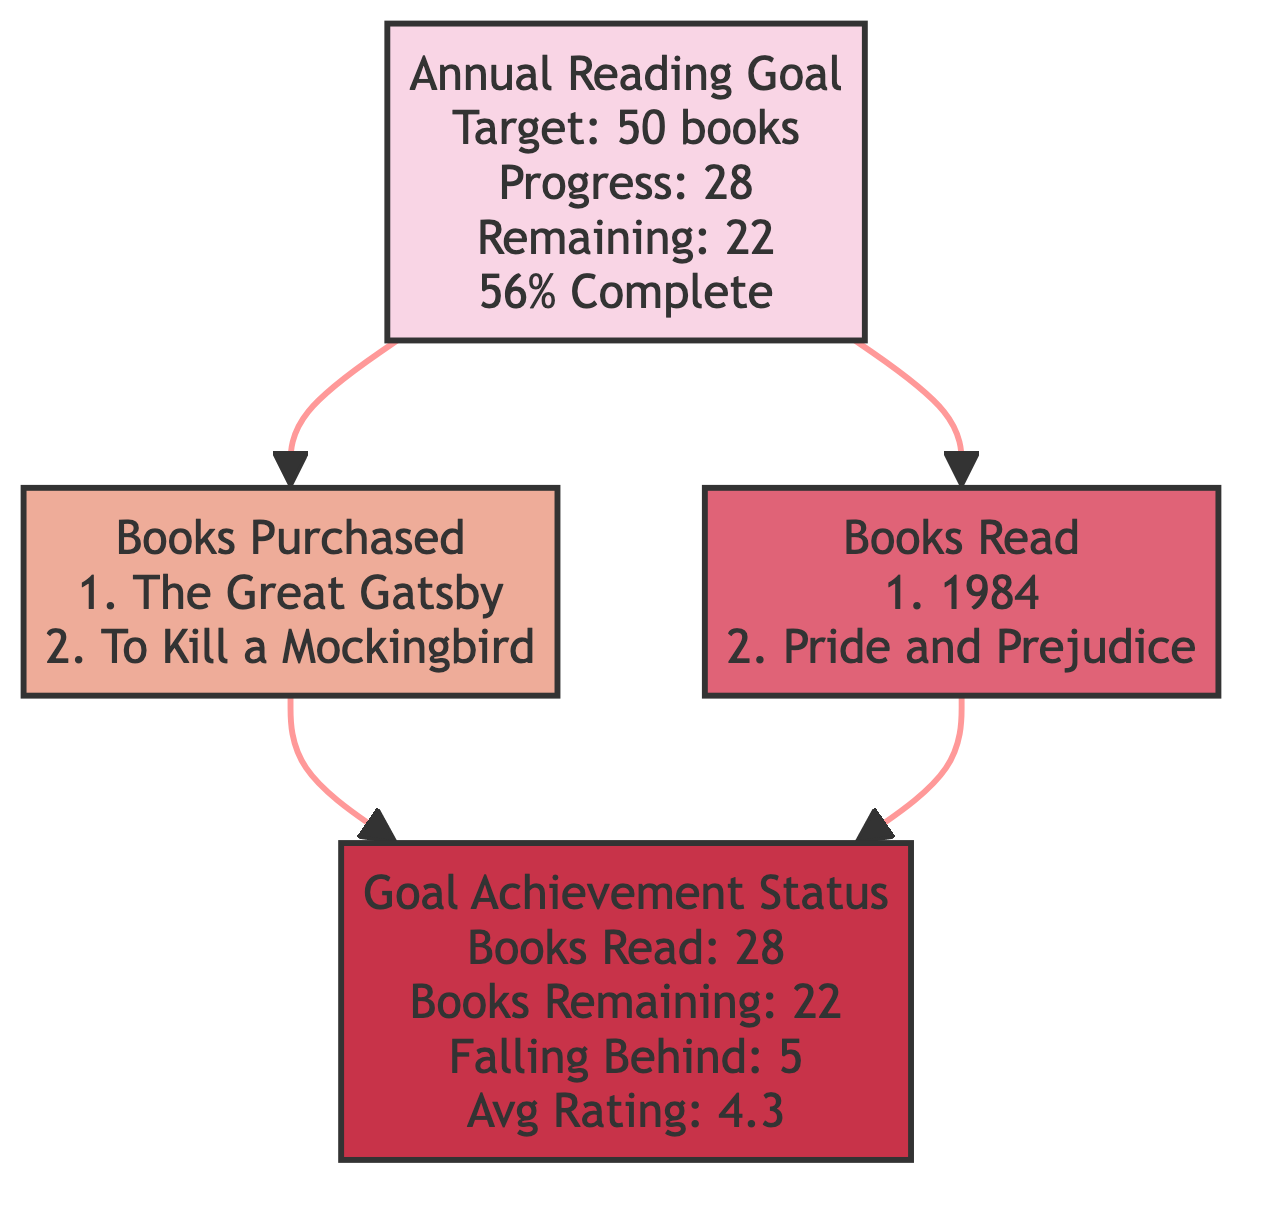What is the target number of books to read in 2023? The diagram indicates that the "Annual Reading Goal" block specifies a target of 50 books for the year 2023. This information is located within the title description of that block.
Answer: 50 How many books have been read so far? In the "Goal Achievement Status" block, it shows that 28 books have been read as of now, found under the "Books Read" attribute within that block.
Answer: 28 What is the average rating of books read? The "Goal Achievement Status" block states that the average rating of the books read is 4.3, which is presented in the "Average Rating Of Books Read" attribute of that block.
Answer: 4.3 How many books are remaining to meet the annual goal? The "Annual Reading Goal" block indicates that there are 22 remaining books to reach the annual target, as shown in the "Remaining" attribute.
Answer: 22 How many books fall behind the reading goal? The "Goal Achievement Status" block specifies that 5 books are falling behind, which is displayed in the "Books Falling Behind" attribute.
Answer: 5 What two books were purchased according to the diagram? According to the "Books Purchased" block, the diagram lists "The Great Gatsby" and "To Kill a Mockingbird" as the two books that have been bought in the year 2023.
Answer: The Great Gatsby, To Kill a Mockingbird How many blocks are in the entire diagram? There are a total of four blocks displayed in the diagram: "Annual Reading Goal," "Books Purchased," "Books Read," and "Goal Achievement Status." By counting each distinct block, we arrive at this total.
Answer: 4 What is the relationship between "Books Purchased" and "Goal Achievement Status"? The relationship is that the "Books Purchased" block feeds into the "Goal Achievement Status" block, meaning that the information regarding books purchased contributes to understanding the overall goal achievement. This is demonstrated by the arrows indicating their connection in the diagram.
Answer: Connection What is the total progress percentage towards the annual reading goal? The "Annual Reading Goal" block provides a progress of 56% towards the goal, which is included in its attributes section. This percentage reflects how far along the reader is towards their target.
Answer: 56% 